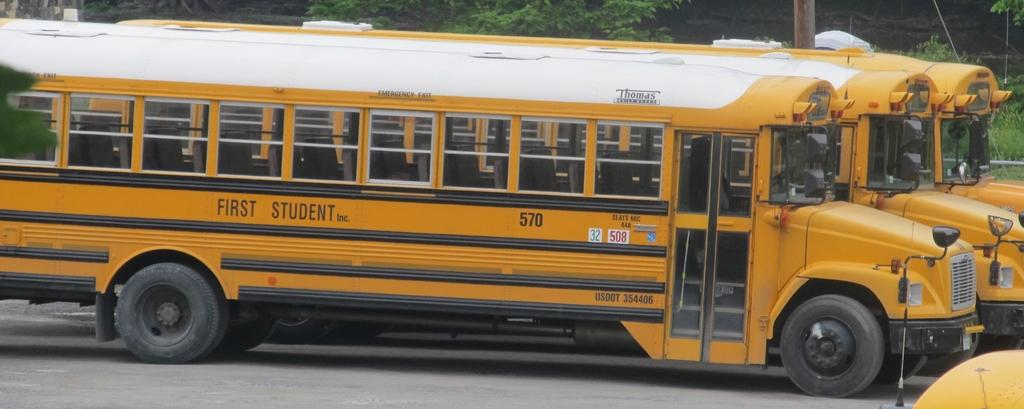What is the main subject of the image? The main subject of the image is buses. Where are the buses located in the image? The buses are on the road in the center of the image. What can be seen in the background of the image? There are trees in the background of the image. What other object is present in the image? There is a pole in the image. How many cows are flying over the buses in the image? There are no cows present in the image, let alone flying over the buses. 